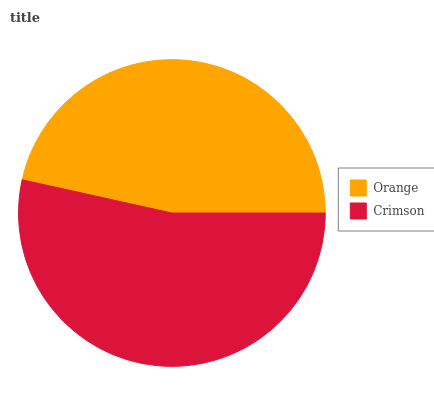Is Orange the minimum?
Answer yes or no. Yes. Is Crimson the maximum?
Answer yes or no. Yes. Is Crimson the minimum?
Answer yes or no. No. Is Crimson greater than Orange?
Answer yes or no. Yes. Is Orange less than Crimson?
Answer yes or no. Yes. Is Orange greater than Crimson?
Answer yes or no. No. Is Crimson less than Orange?
Answer yes or no. No. Is Crimson the high median?
Answer yes or no. Yes. Is Orange the low median?
Answer yes or no. Yes. Is Orange the high median?
Answer yes or no. No. Is Crimson the low median?
Answer yes or no. No. 